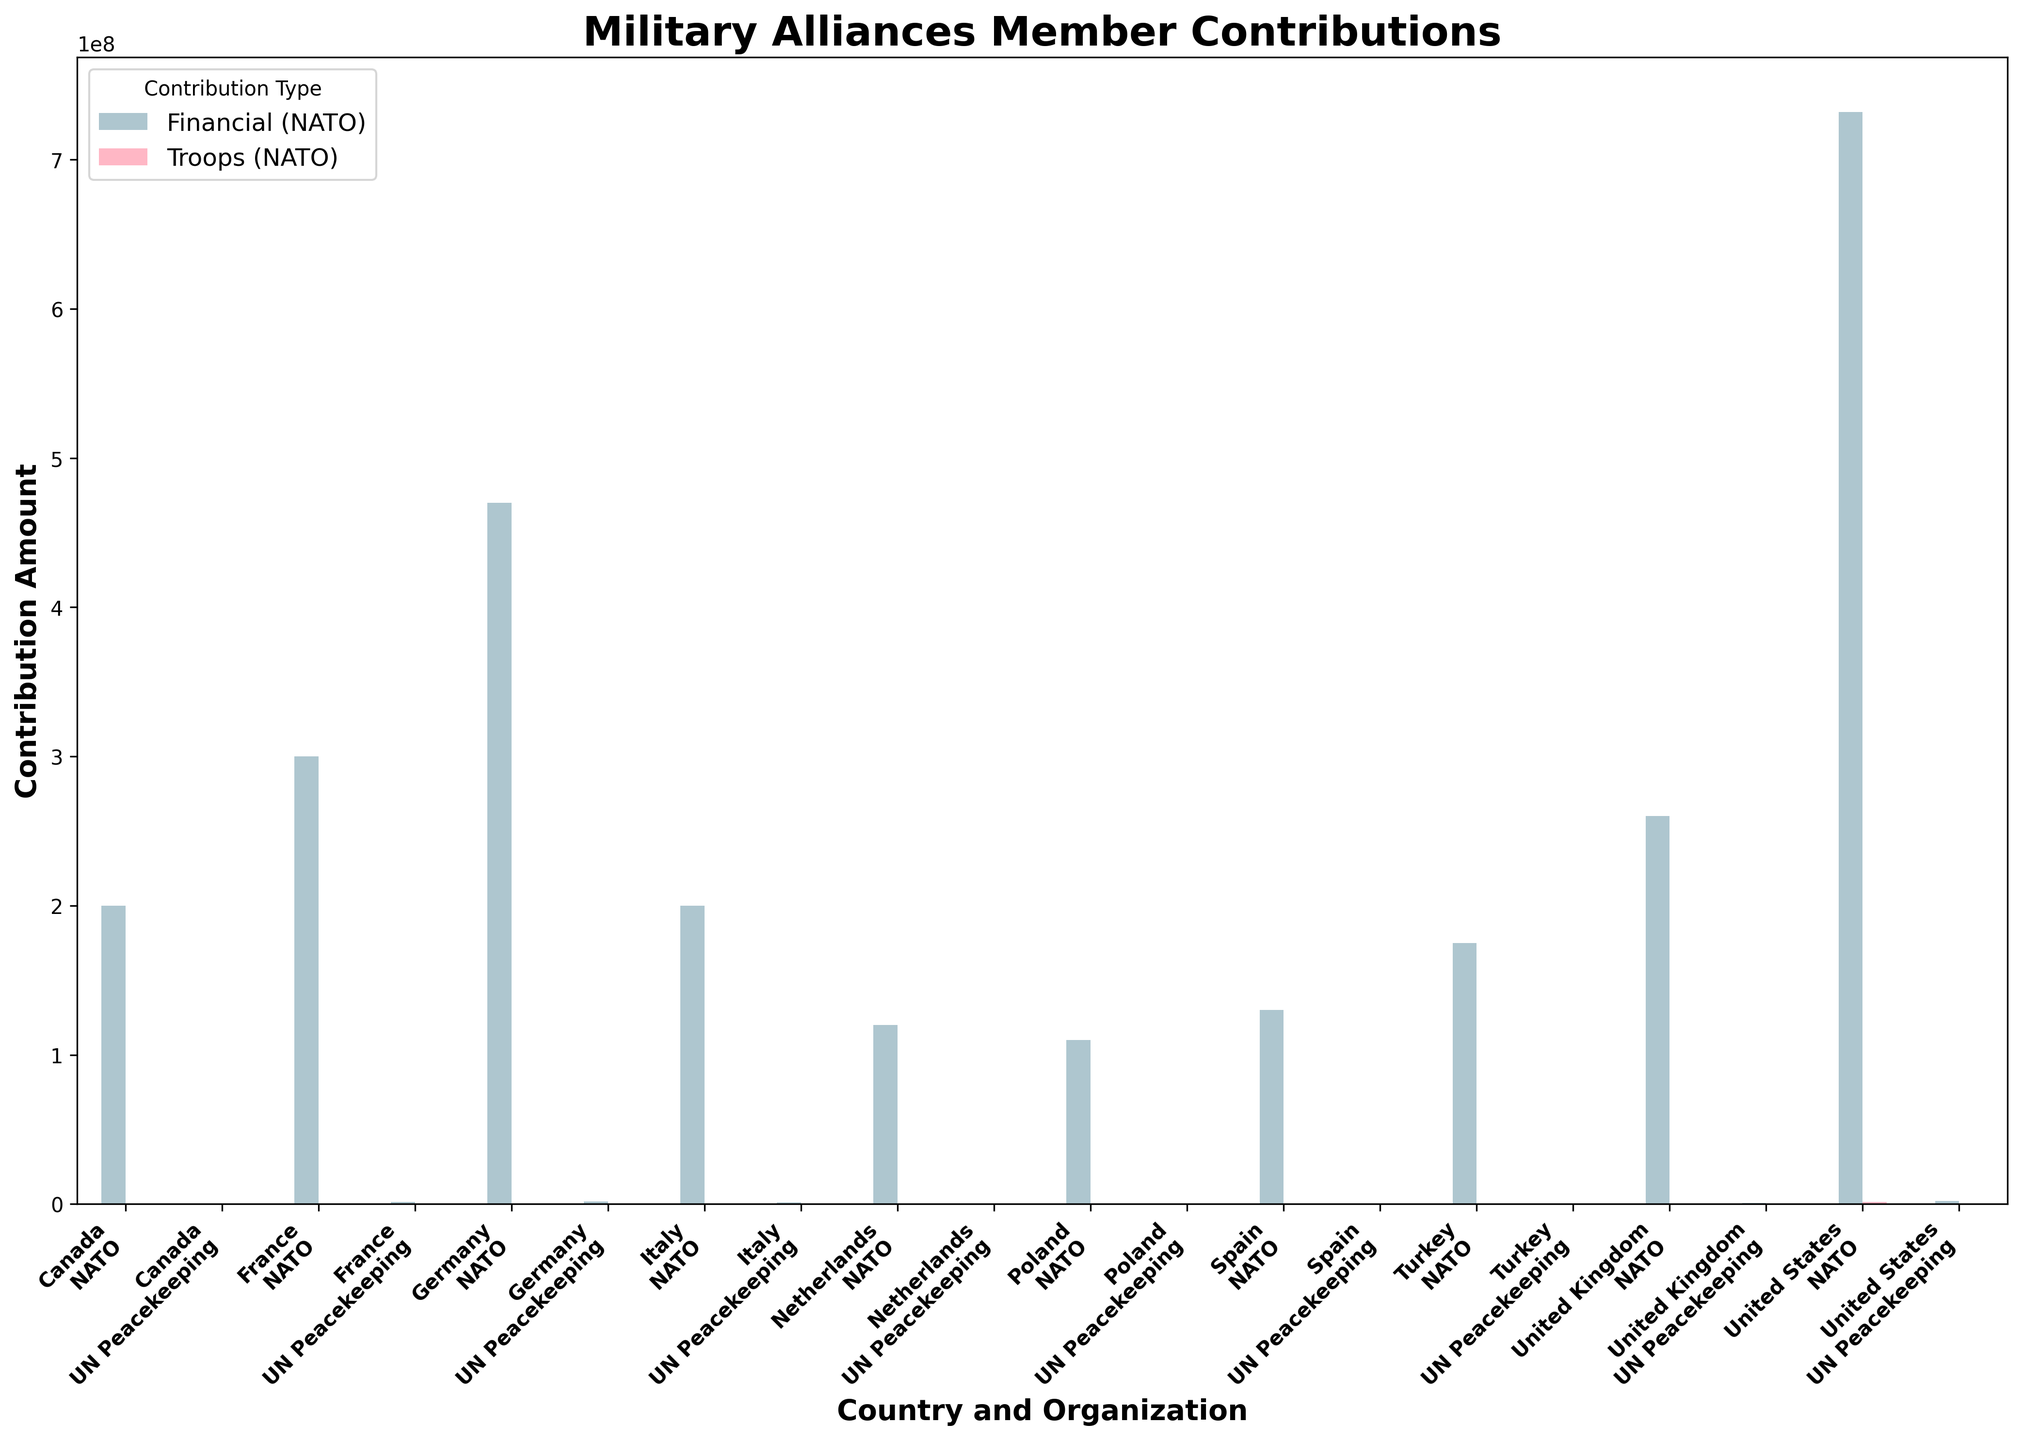Which country contributes the most financially to NATO and how much? The highest bar in the 'Financial (NATO)' category is the one representing the United States. From the bar height, it is clear the contribution is the highest compared to other countries. The bar label reads 732,000,000.
Answer: United States, 732,000,000 Which country has the lowest troop contribution to UN Peacekeeping? By examining the heights of the bars for 'Troops (UN Peacekeeping)', the shortest bar belongs to Spain with a troop contribution of 75.
Answer: Spain, 75 What is the total financial contribution of Germany to both NATO and UN Peacekeeping? For Germany, the bars representing 'Financial (NATO)' and 'Financial (UN Peacekeeping)' need to be summed. These are found to be 470,000,000 and 1,700,000 respectively. Adding these values: 470,000,000 + 1,700,000 = 471,700,000.
Answer: 471,700,000 Which country has a higher contribution of troops to NATO, Germany or Spain, and by how much? The bars indicating 'Troops (NATO)' for Germany and Spain show 180,000 troops for Germany and 50,000 troops for Spain. The difference is 180,000 - 50,000 = 130,000.
Answer: Germany, 130,000 Compare the financial contribution to UN Peacekeeping between France and Canada. Which one is higher and by how much? The 'Financial (UN Peacekeeping)' bars for France and Canada indicate contributions of 1,400,000 and 500,000 respectively. Hence, France contributes more by 1,400,000 - 500,000 = 900,000.
Answer: France, 900,000 What is the average financial contribution to NATO by the listed countries? Sum all the 'Financial (NATO)' contributions: 732,000,000 (US) + 470,000,000 (Germany) + 260,000,000 (UK) + 300,000,000 (France) + 200,000,000 (Italy) + 200,000,000 (Canada) + 175,000,000 (Turkey) + 120,000,000 (Netherlands) + 130,000,000 (Spain) + 110,000,000 (Poland) = 2,697,000,000. Divide by 10 (number of countries), 2,697,000,000 ÷ 10 = 269,700,000.
Answer: 269,700,000 Between the United States and Canada, which country contributes more troops to UN Peacekeeping, and by how much? The bars for 'Troops (UN Peacekeeping)' for the United States and Canada show 500 and 150 respectively. The United States contributes more by 500 - 150 = 350.
Answer: United States, 350 How does the financial contribution of Turkey to NATO compare to its troop contribution? The bars for Turkey show a financial contribution of 175,000,000 and a troop contribution of 50,000. Visually, the financial contribution is significantly higher.
Answer: Financial contribution is higher Which country has the smallest total contribution (both financial and troops) to NATO? Summing up both financial and troop contributions to NATO for each country and comparing visually, the Netherlands shows significantly smaller bars in both categories.
Answer: Netherlands 